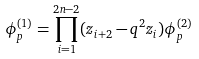<formula> <loc_0><loc_0><loc_500><loc_500>\phi ^ { ( 1 ) } _ { p } = \prod _ { i = 1 } ^ { 2 n - 2 } ( z _ { i + 2 } - q ^ { 2 } z _ { i } ) \phi ^ { ( 2 ) } _ { p }</formula> 